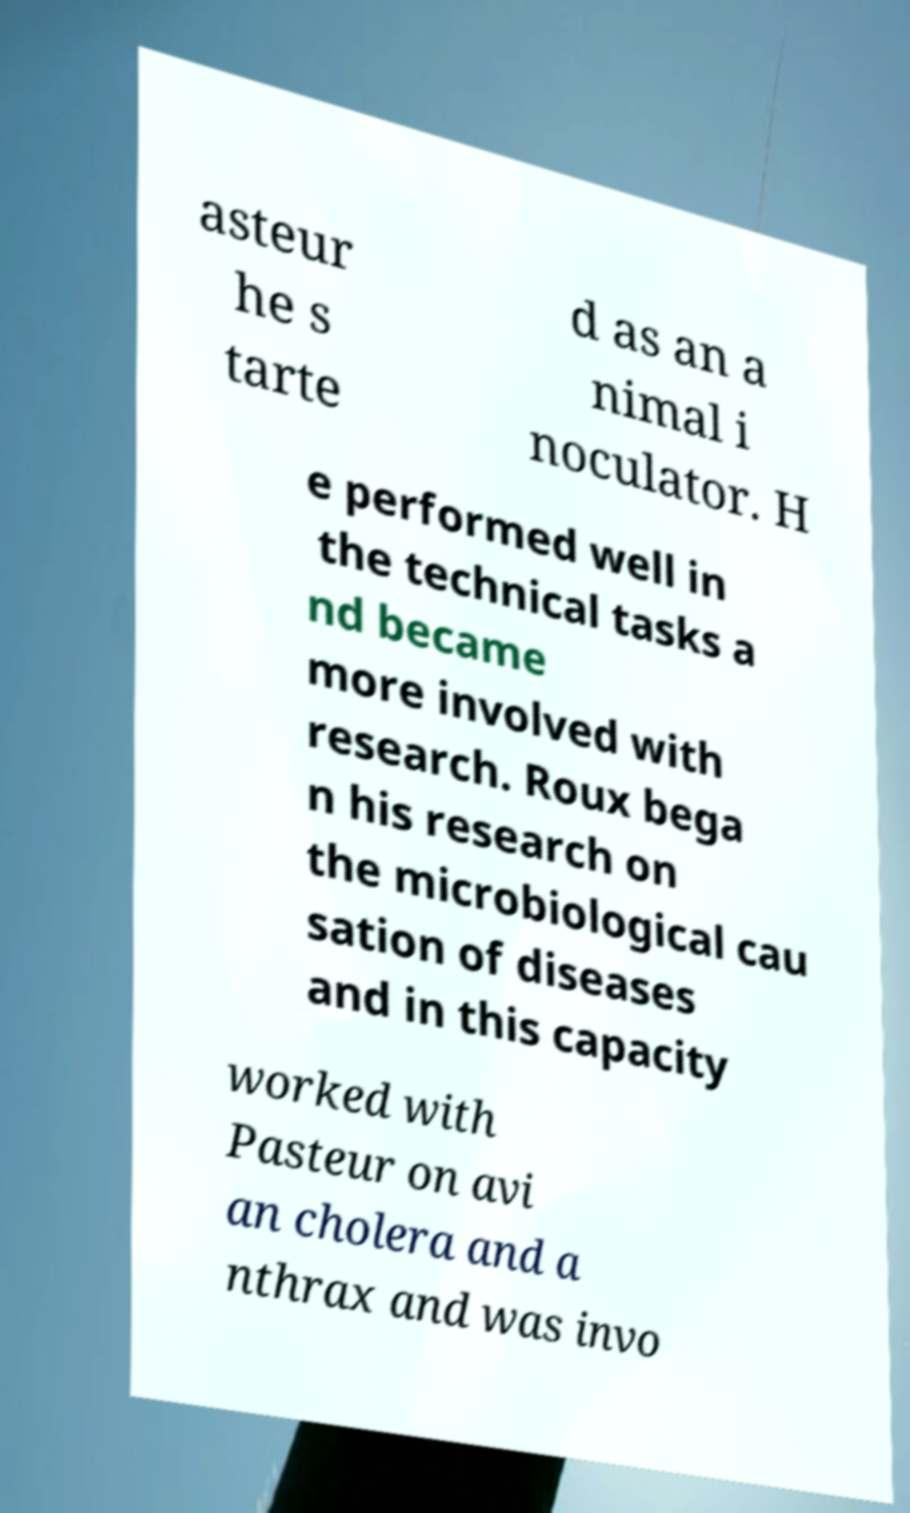Can you read and provide the text displayed in the image?This photo seems to have some interesting text. Can you extract and type it out for me? asteur he s tarte d as an a nimal i noculator. H e performed well in the technical tasks a nd became more involved with research. Roux bega n his research on the microbiological cau sation of diseases and in this capacity worked with Pasteur on avi an cholera and a nthrax and was invo 